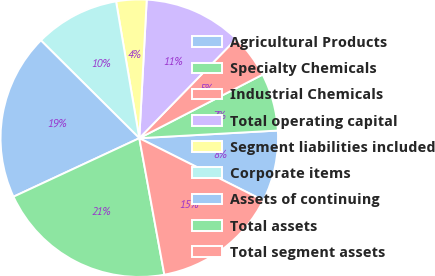<chart> <loc_0><loc_0><loc_500><loc_500><pie_chart><fcel>Agricultural Products<fcel>Specialty Chemicals<fcel>Industrial Chemicals<fcel>Total operating capital<fcel>Segment liabilities included<fcel>Corporate items<fcel>Assets of continuing<fcel>Total assets<fcel>Total segment assets<nl><fcel>8.28%<fcel>6.7%<fcel>5.12%<fcel>11.45%<fcel>3.53%<fcel>9.87%<fcel>19.38%<fcel>20.96%<fcel>14.71%<nl></chart> 